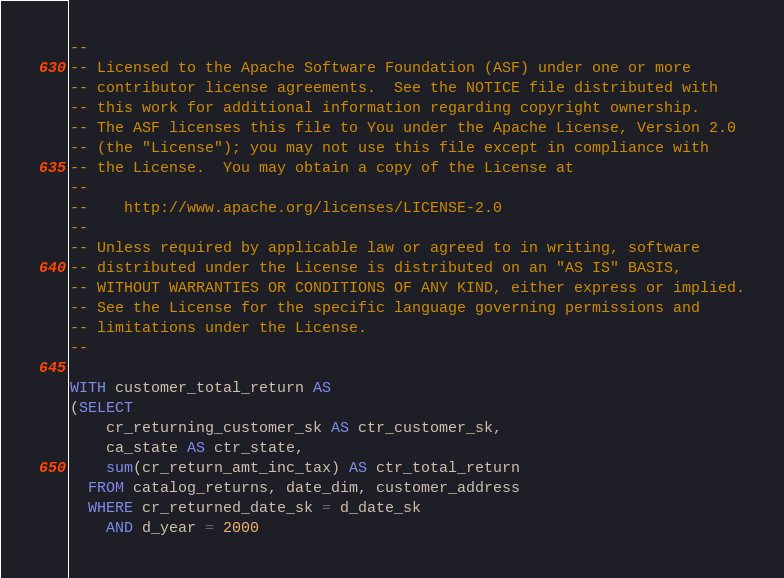Convert code to text. <code><loc_0><loc_0><loc_500><loc_500><_SQL_>--
-- Licensed to the Apache Software Foundation (ASF) under one or more
-- contributor license agreements.  See the NOTICE file distributed with
-- this work for additional information regarding copyright ownership.
-- The ASF licenses this file to You under the Apache License, Version 2.0
-- (the "License"); you may not use this file except in compliance with
-- the License.  You may obtain a copy of the License at
--
--    http://www.apache.org/licenses/LICENSE-2.0
--
-- Unless required by applicable law or agreed to in writing, software
-- distributed under the License is distributed on an "AS IS" BASIS,
-- WITHOUT WARRANTIES OR CONDITIONS OF ANY KIND, either express or implied.
-- See the License for the specific language governing permissions and
-- limitations under the License.
--

WITH customer_total_return AS
(SELECT
    cr_returning_customer_sk AS ctr_customer_sk,
    ca_state AS ctr_state,
    sum(cr_return_amt_inc_tax) AS ctr_total_return
  FROM catalog_returns, date_dim, customer_address
  WHERE cr_returned_date_sk = d_date_sk
    AND d_year = 2000</code> 